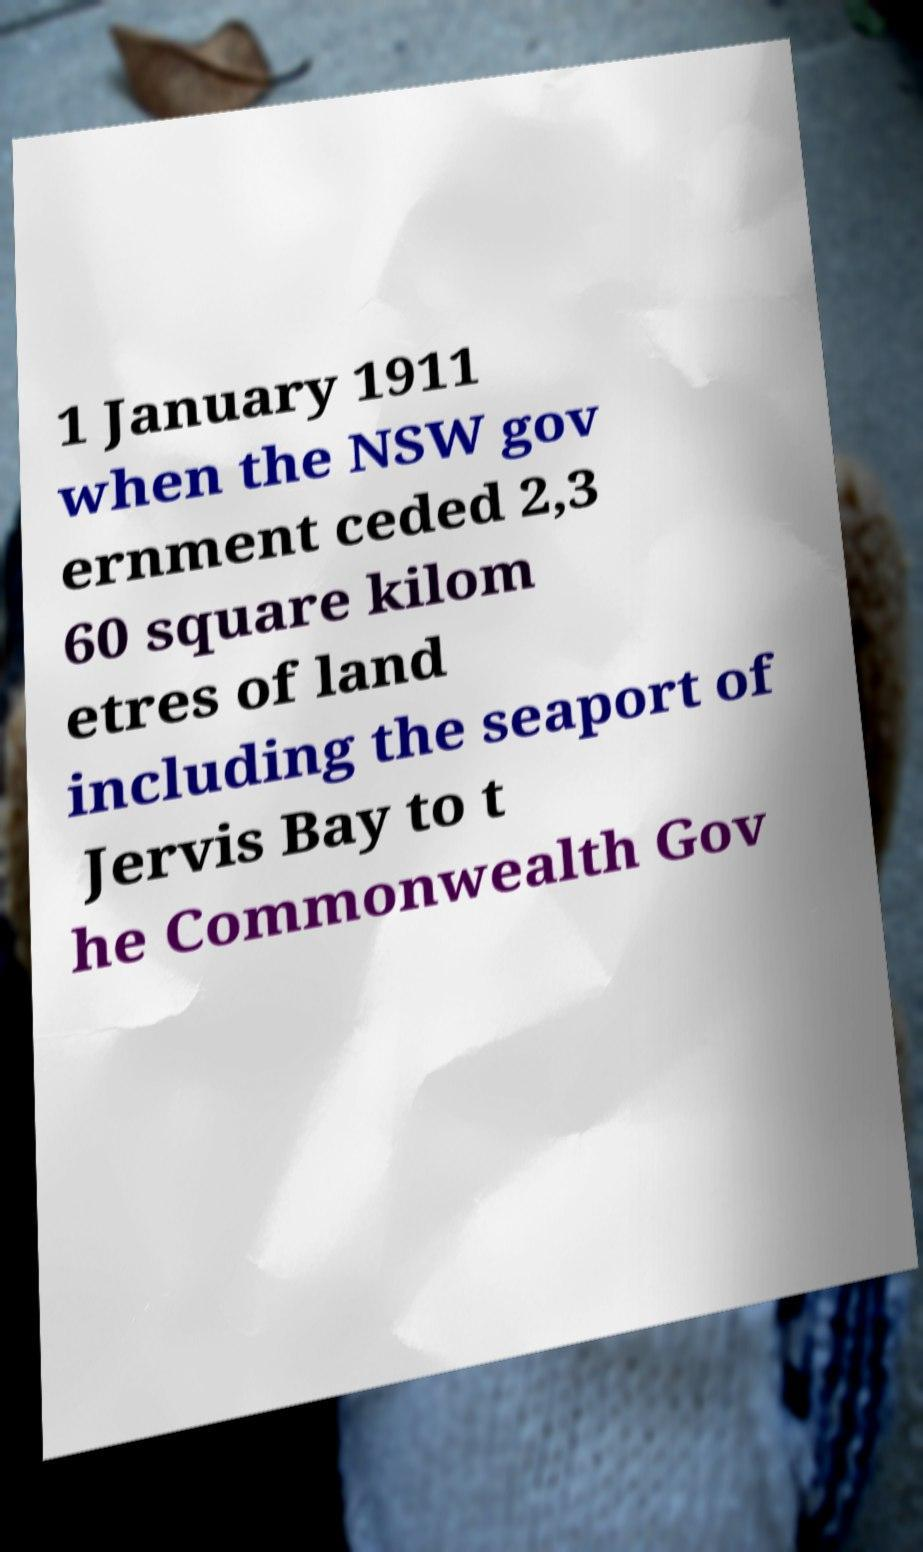I need the written content from this picture converted into text. Can you do that? 1 January 1911 when the NSW gov ernment ceded 2,3 60 square kilom etres of land including the seaport of Jervis Bay to t he Commonwealth Gov 